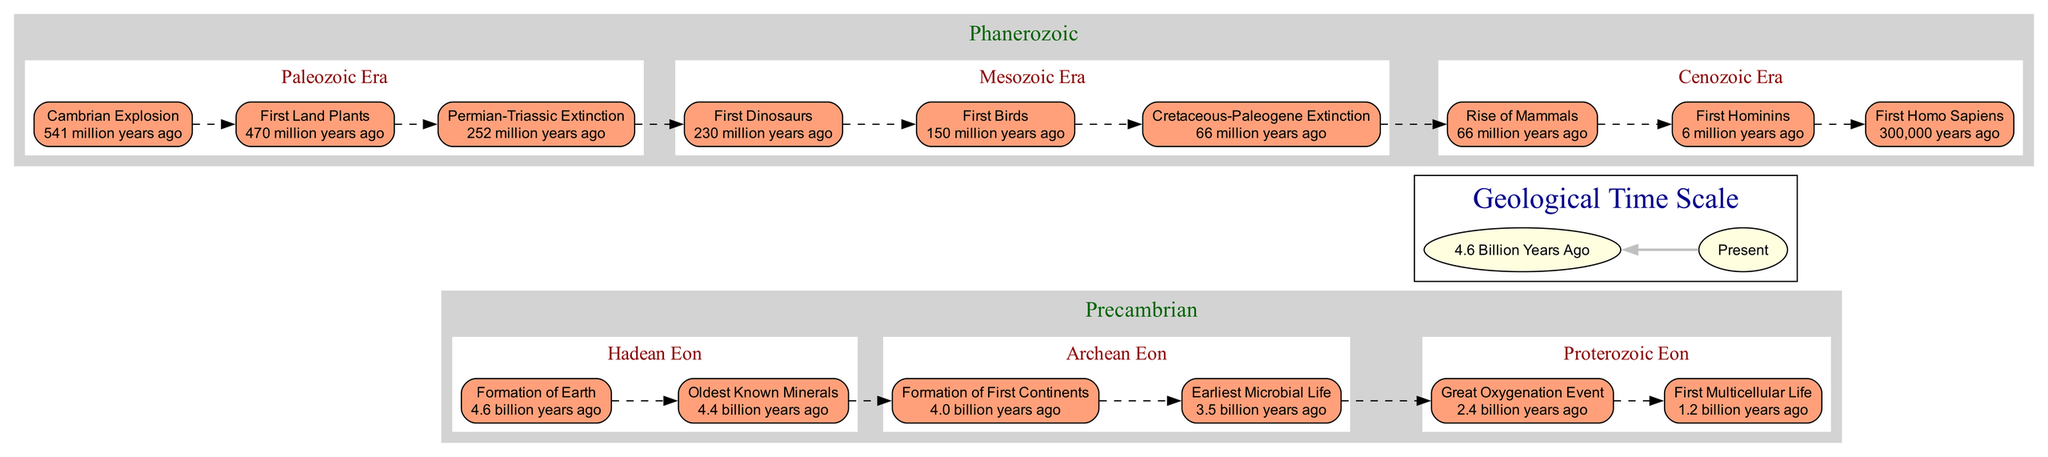What is the time of the Great Oxygenation Event? The diagram indicates that the Great Oxygenation Event occurred 2.4 billion years ago under the Proterozoic Eon.
Answer: 2.4 billion years ago How many events are listed under the Paleozoic Era? There are three events listed under the Paleozoic Era: Cambrian Explosion, First Land Plants, and Permian-Triassic Extinction.
Answer: 3 What event occurred most recently in Earth's history according to the diagram? The diagram shows that the most recent event is the appearance of the First Homo Sapiens at 300,000 years ago, which is the last node before the "Present."
Answer: First Homo Sapiens Which eon contains the formation of the first continents? The formation of the first continents occurred during the Archean Eon, as noted in the sub-events listed under the Precambrian section.
Answer: Archean Eon What major event coincides with the end of the Mesozoic Era? The Cretaceous-Paleogene Extinction event coincides with the end of the Mesozoic Era, occurring 66 million years ago.
Answer: Cretaceous-Paleogene Extinction How are the subsections within the Precambrian group organized? The subsections within the Precambrian group are organized chronologically from oldest to most recent: Hadean Eon, Archean Eon, and Proterozoic Eon.
Answer: Chronologically What is the sequence of events in the Cenozoic Era? In the Cenozoic Era, the sequence of events is: Rise of Mammals at 66 million years ago, followed by the First Hominins at 6 million years ago, and finally the First Homo Sapiens at 300,000 years ago.
Answer: Rise of Mammals, First Hominins, First Homo Sapiens How does the timeline represent the relationship between the oldest known minerals and the formation of Earth? The timeline shows that the formation of Earth occurred first at 4.6 billion years ago, followed shortly by the Oldest Known Minerals at 4.4 billion years ago, indicating a sequential relationship.
Answer: Sequential Which significant life form appeared first according to the diagram? The diagram notes that the earliest microbial life appeared first at 3.5 billion years ago in the Archean Eon, before the appearance of multicellular life.
Answer: Earliest Microbial Life 